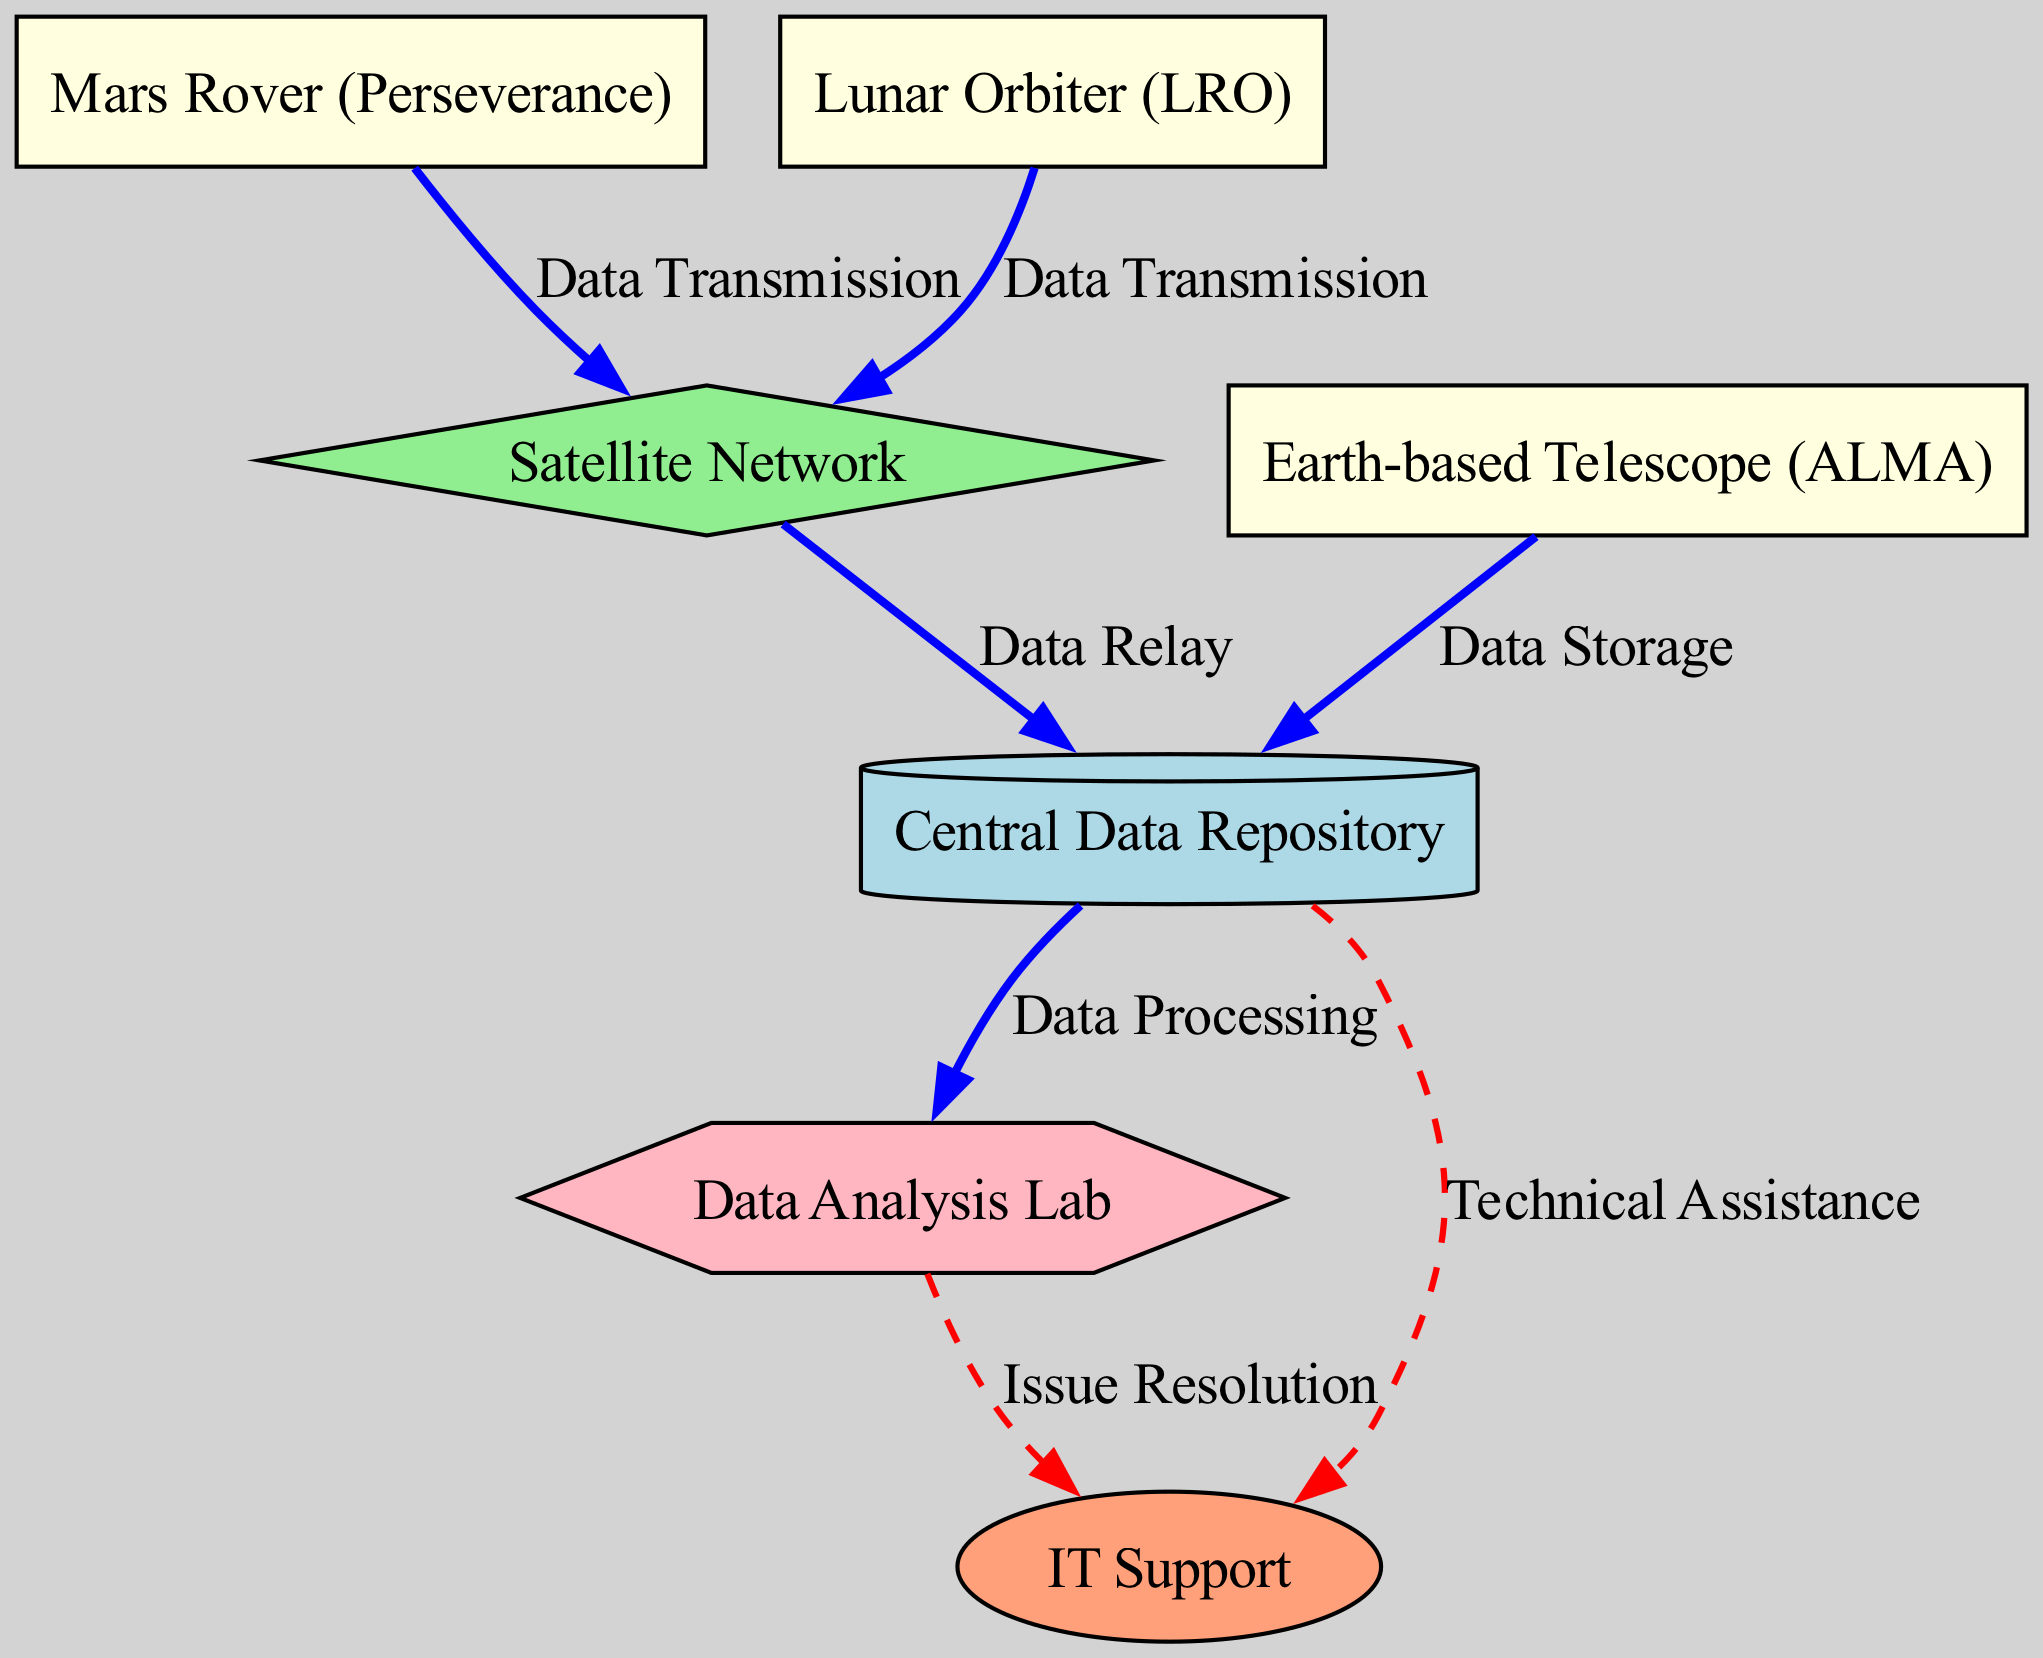What is the name of the storage node in the diagram? The diagram identifies the storage node as "Central Data Repository." This can be found among the nodes listed and is designated specifically as a storage type.
Answer: Central Data Repository How many survey nodes are present? Counting the nodes with the type "survey," we find three nodes: Mars Rover, Lunar Orbiter, and Earth-based Telescope. Thus, there are a total of three survey nodes.
Answer: 3 What type of node is the Lunar Orbiter? The diagram specifies that the Lunar Orbiter is classified as a "survey" type node. It can be directly identified within the nodes list.
Answer: survey Which node does the Mars Rover transmit data to? Reviewing the edges, the Mars Rover data transmission flows directly to the Satellite Network. This is clearly indicated in the diagram's edges section.
Answer: Satellite Network What type of flow connects the Data Center to the Data Analysis Lab? The connection from the Data Center to the Data Analysis Lab is labeled as "Data Processing," which indicates the type of flow in that particular edge. It is defined as a data flow type.
Answer: Data Processing Which support-related interaction occurs between the Data Center and IT Support? The diagram illustrates a flow labeled "Technical Assistance" between the Data Center and IT Support, which indicates a support-related interaction directed toward providing technical services.
Answer: Technical Assistance Identify one potential bottleneck in data flow based on the diagram. The Satellite Network acts as a potential bottleneck since it receives data from both the Mars Rover and the Lunar Orbiter before relaying it to the Data Center. This can lead to congestion if either survey experiences high data transmission loads.
Answer: Satellite Network What is the purpose of the edge labeled "Issue Resolution"? The edge labeled "Issue Resolution" depicts a support flow from the Analysis Lab to IT Support. It signifies a process where the analysis lab communicates issues that require resolution to the IT Support team.
Answer: Issue Resolution 